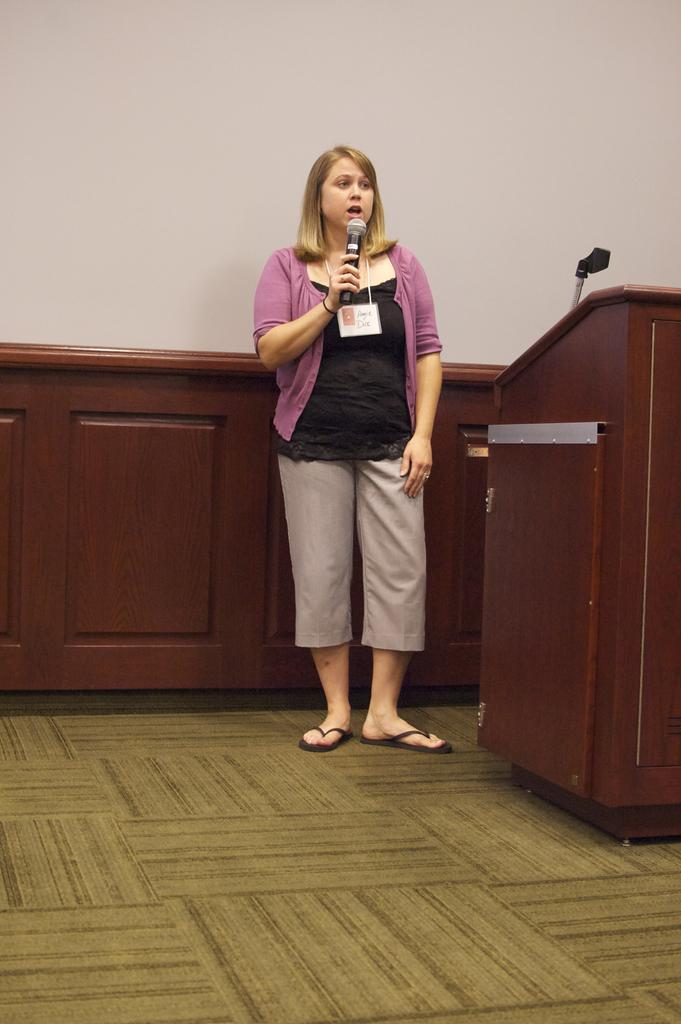Who is the main subject in the image? There is a woman in the image. What is the woman doing in the image? The woman is standing in front of a podium. What object is the woman holding in her hand? The woman is holding a microphone in her hand. What can be seen behind the woman in the image? There is a wall at the back side of the image. How much payment is the woman receiving for playing the drum in the image? There is no drum or payment mentioned in the image; the woman is holding a microphone and standing in front of a podium. 